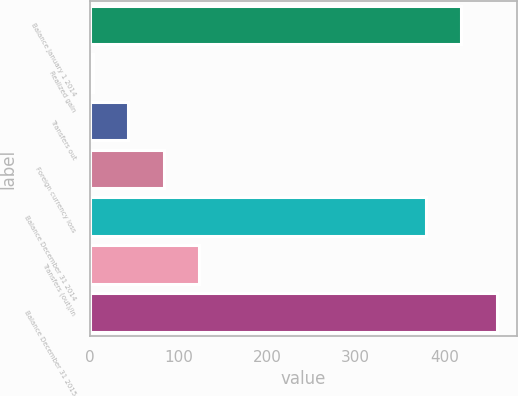<chart> <loc_0><loc_0><loc_500><loc_500><bar_chart><fcel>Balance January 1 2014<fcel>Realized gain<fcel>Transfers out<fcel>Foreign currency loss<fcel>Balance December 31 2014<fcel>Transfers (out)/in<fcel>Balance December 31 2015<nl><fcel>419.2<fcel>3<fcel>43.2<fcel>83.4<fcel>379<fcel>123.6<fcel>459.4<nl></chart> 